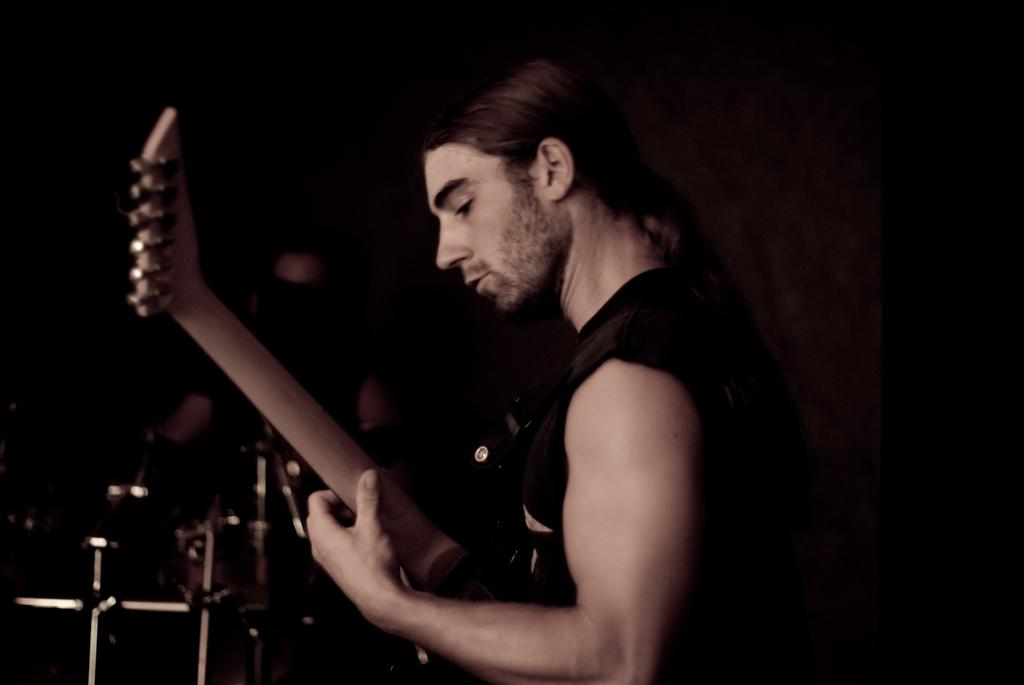What is the main subject of the image? There is a person in the image. What is the person in the image wearing? The person is wearing a black dress. What is the person in the image doing? The person is playing musical instruments. Can you describe the background of the image? There is another person in the background of the image, and they are also playing musical instruments. What expert decision can be seen being made in the image? There is no expert decision being made in the image; it features two people playing musical instruments. What rate of success can be observed in the image? There is no indication of success or failure in the image, as it simply shows two people playing musical instruments. 